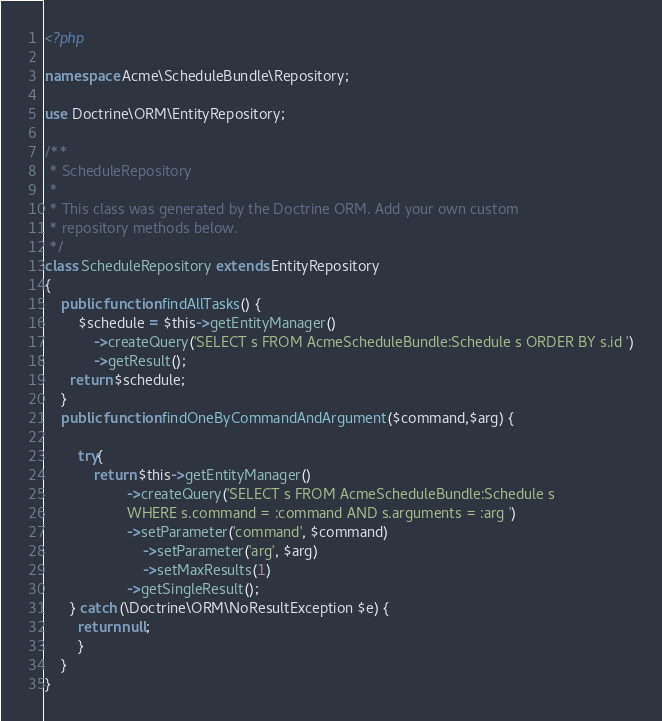Convert code to text. <code><loc_0><loc_0><loc_500><loc_500><_PHP_><?php

namespace Acme\ScheduleBundle\Repository;

use Doctrine\ORM\EntityRepository;

/**
 * ScheduleRepository
 *
 * This class was generated by the Doctrine ORM. Add your own custom
 * repository methods below.
 */
class ScheduleRepository extends EntityRepository
{
	public function findAllTasks() {
		$schedule = $this->getEntityManager()
            ->createQuery('SELECT s FROM AcmeScheduleBundle:Schedule s ORDER BY s.id ')
            ->getResult();
      return $schedule;
	}
	public function findOneByCommandAndArgument($command,$arg) {
		
		try{
			return $this->getEntityManager()
            		->createQuery('SELECT s FROM AcmeScheduleBundle:Schedule s 
            		WHERE s.command = :command AND s.arguments = :arg ')
            		->setParameter('command', $command)
						->setParameter('arg', $arg)
						->setMaxResults(1)
            		->getSingleResult();
      } catch (\Doctrine\ORM\NoResultException $e) {
        return null;
    	}
	}
}</code> 